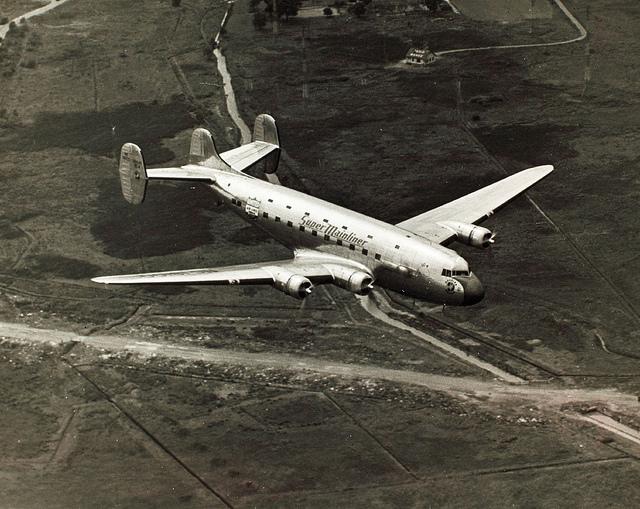How can you tell this plane is meant for long distance travel?
Answer briefly. Size. What does the plane say above the wing?
Be succinct. Super mainliner. Is the plane grounded?
Give a very brief answer. No. 